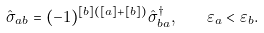<formula> <loc_0><loc_0><loc_500><loc_500>\hat { \sigma } _ { a b } = ( - 1 ) ^ { [ b ] ( [ a ] + [ b ] ) } \hat { \sigma } _ { b a } ^ { \dagger } , \quad \varepsilon _ { a } < \varepsilon _ { b } .</formula> 